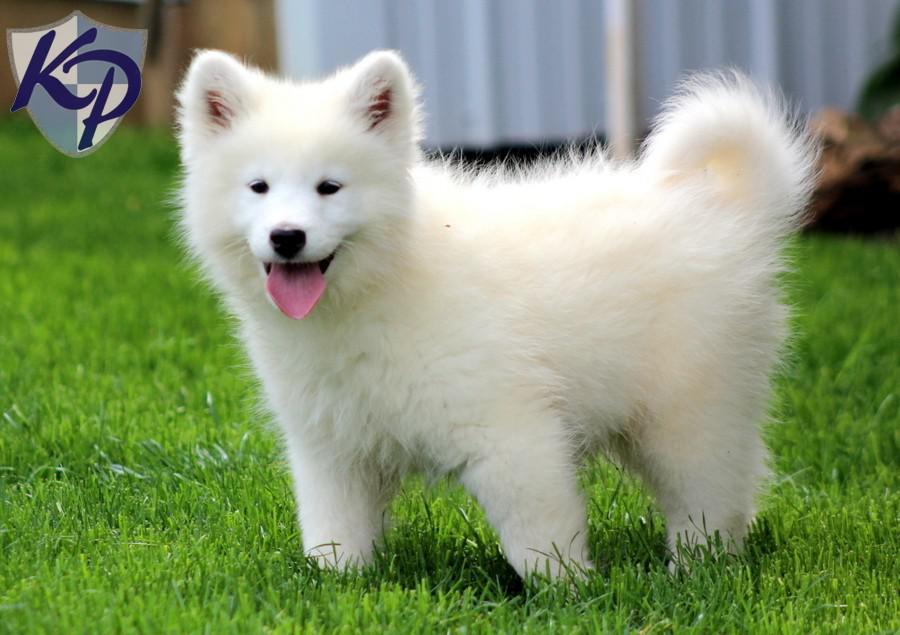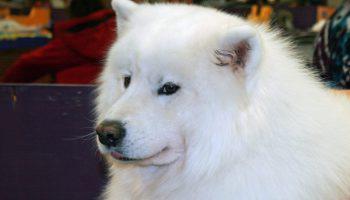The first image is the image on the left, the second image is the image on the right. Examine the images to the left and right. Is the description "Two dogs are in a grassy area in the image on the right." accurate? Answer yes or no. No. The first image is the image on the left, the second image is the image on the right. Examine the images to the left and right. Is the description "there is a dog standing on the grass with a row of trees behind it" accurate? Answer yes or no. No. 